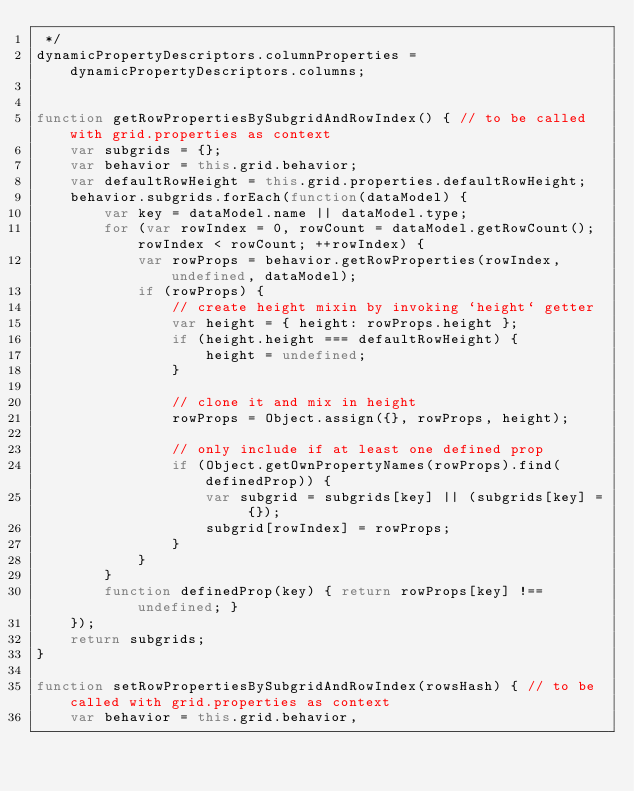<code> <loc_0><loc_0><loc_500><loc_500><_JavaScript_> */
dynamicPropertyDescriptors.columnProperties = dynamicPropertyDescriptors.columns;


function getRowPropertiesBySubgridAndRowIndex() { // to be called with grid.properties as context
    var subgrids = {};
    var behavior = this.grid.behavior;
    var defaultRowHeight = this.grid.properties.defaultRowHeight;
    behavior.subgrids.forEach(function(dataModel) {
        var key = dataModel.name || dataModel.type;
        for (var rowIndex = 0, rowCount = dataModel.getRowCount(); rowIndex < rowCount; ++rowIndex) {
            var rowProps = behavior.getRowProperties(rowIndex, undefined, dataModel);
            if (rowProps) {
                // create height mixin by invoking `height` getter
                var height = { height: rowProps.height };
                if (height.height === defaultRowHeight) {
                    height = undefined;
                }

                // clone it and mix in height
                rowProps = Object.assign({}, rowProps, height);

                // only include if at least one defined prop
                if (Object.getOwnPropertyNames(rowProps).find(definedProp)) {
                    var subgrid = subgrids[key] || (subgrids[key] = {});
                    subgrid[rowIndex] = rowProps;
                }
            }
        }
        function definedProp(key) { return rowProps[key] !== undefined; }
    });
    return subgrids;
}

function setRowPropertiesBySubgridAndRowIndex(rowsHash) { // to be called with grid.properties as context
    var behavior = this.grid.behavior,</code> 